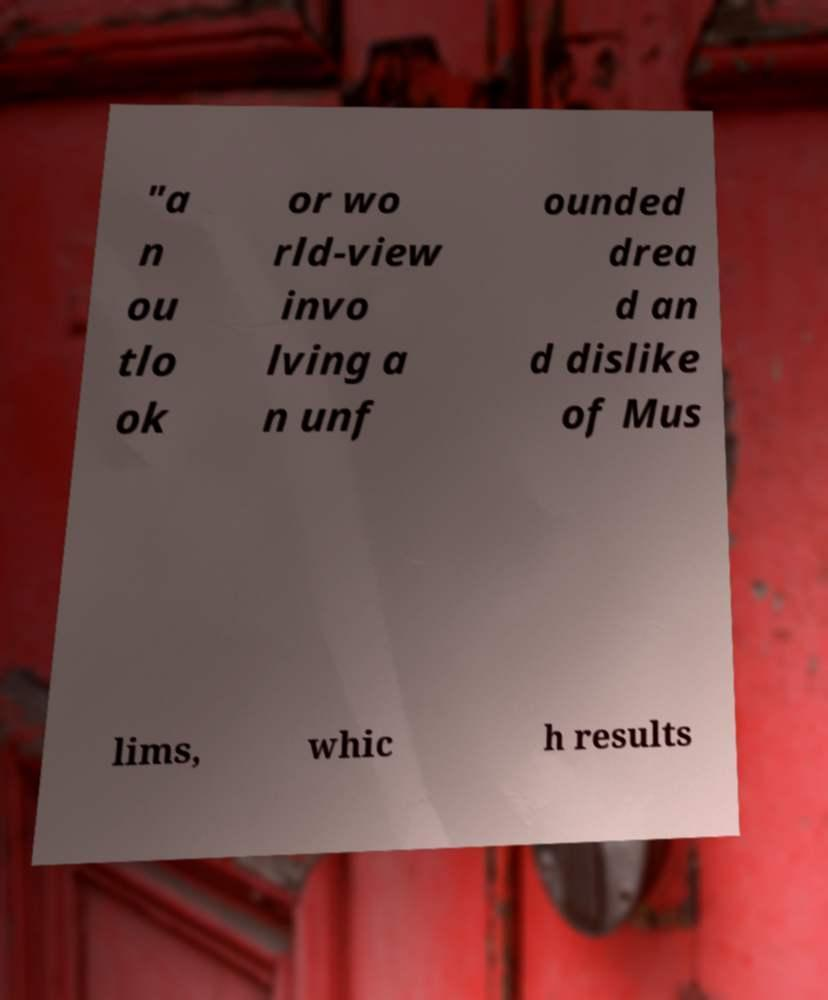Please read and relay the text visible in this image. What does it say? "a n ou tlo ok or wo rld-view invo lving a n unf ounded drea d an d dislike of Mus lims, whic h results 